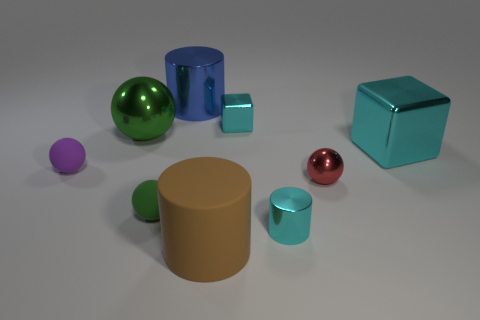The large green thing that is the same material as the blue object is what shape?
Keep it short and to the point. Sphere. Do the cylinder that is on the left side of the brown rubber cylinder and the tiny red shiny object have the same size?
Keep it short and to the point. No. There is a large object that is in front of the cyan block right of the cyan cylinder; what shape is it?
Offer a terse response. Cylinder. There is a block that is in front of the tiny cyan metal thing that is behind the tiny metallic cylinder; what is its size?
Keep it short and to the point. Large. The large thing that is in front of the red sphere is what color?
Keep it short and to the point. Brown. There is a cylinder that is made of the same material as the small purple thing; what size is it?
Give a very brief answer. Large. What number of tiny purple rubber things have the same shape as the large matte thing?
Offer a terse response. 0. What is the material of the cyan cube that is the same size as the brown rubber object?
Ensure brevity in your answer.  Metal. Is there a big block that has the same material as the blue cylinder?
Give a very brief answer. Yes. What is the color of the shiny object that is on the right side of the small cyan cylinder and on the left side of the large metal cube?
Give a very brief answer. Red. 